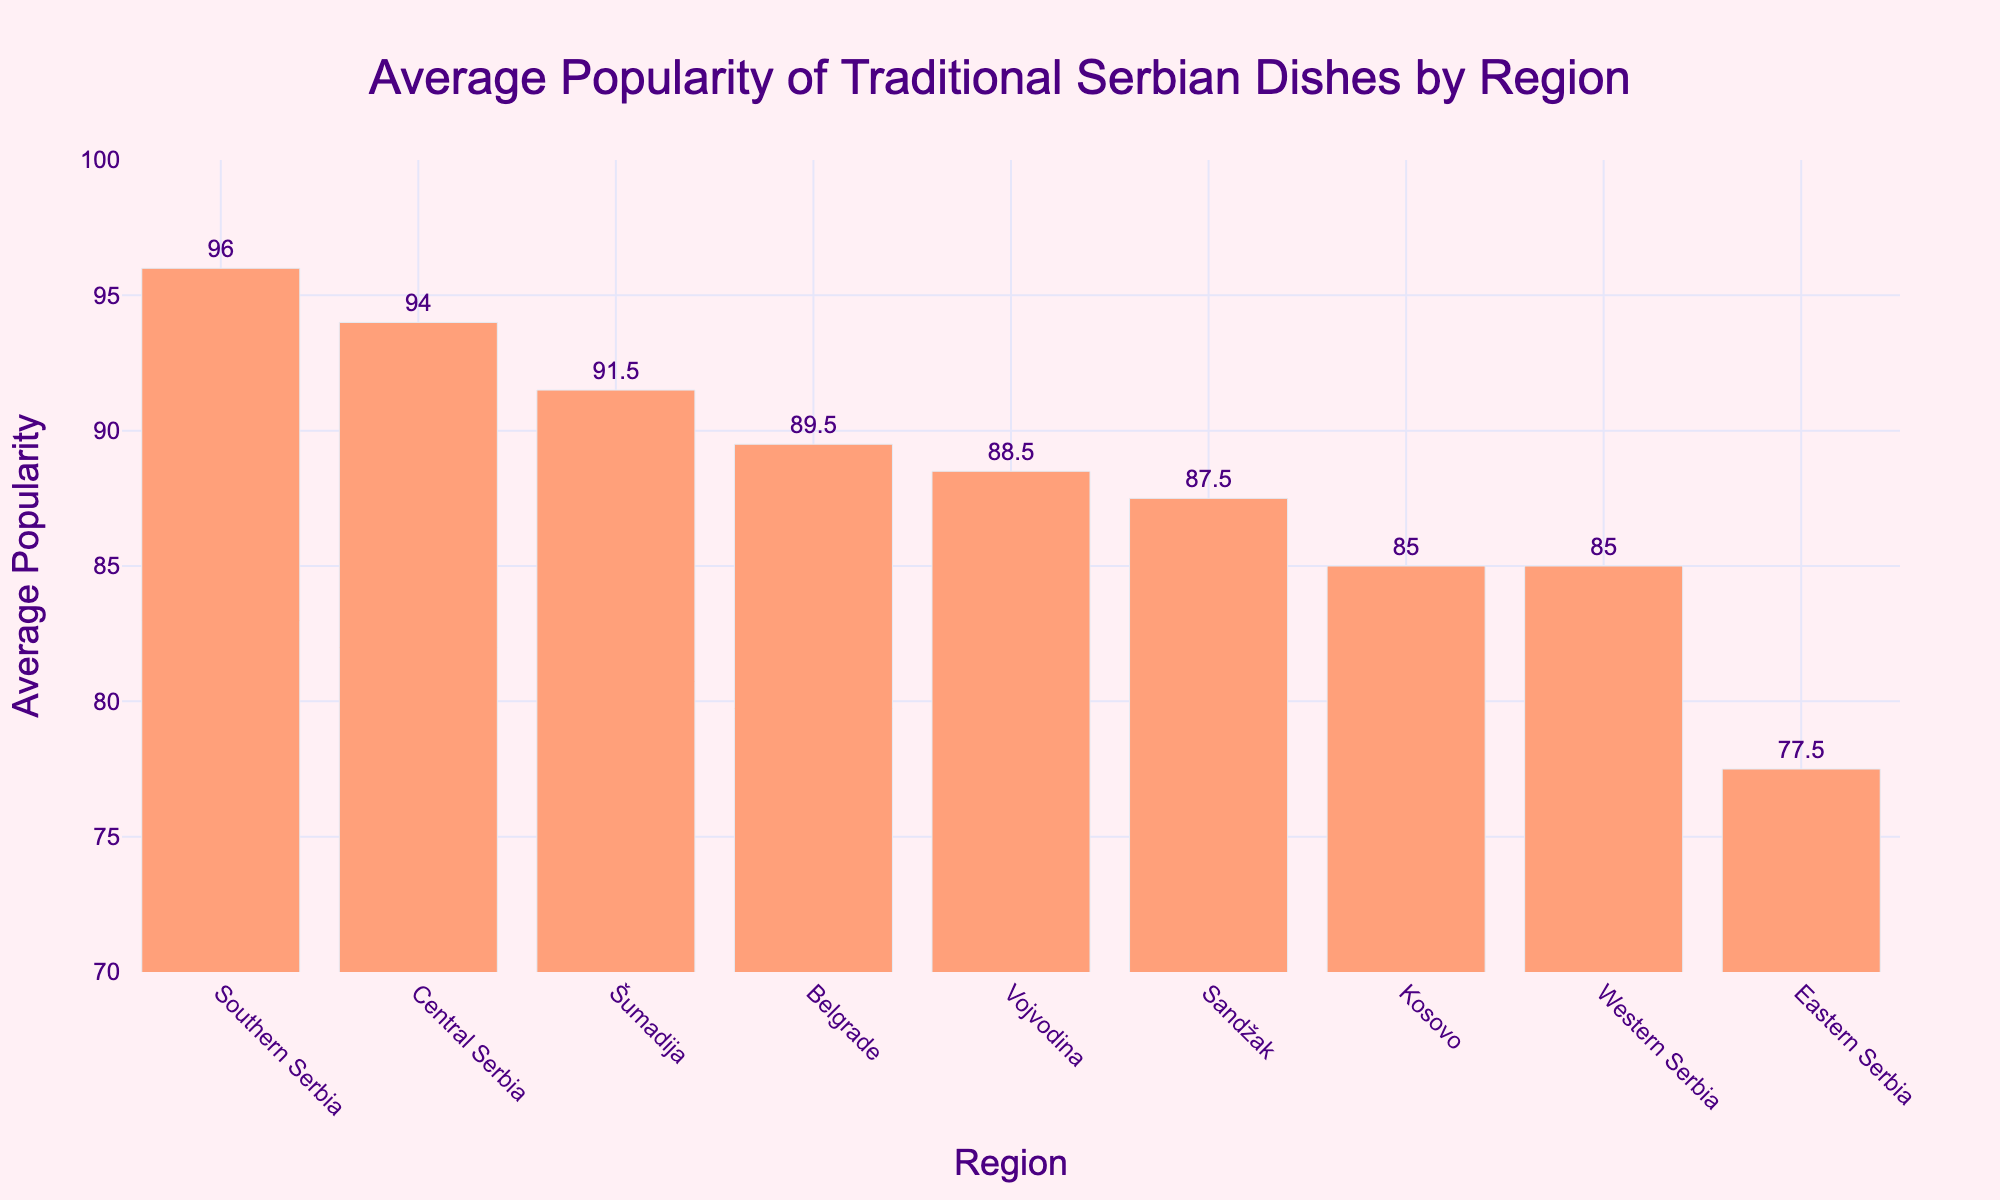Which region has the highest average popularity of traditional Serbian dishes? By looking at the heights of the bars in the bar chart, the bar for Central Serbia is the highest, indicating that this region has the highest average popularity of traditional Serbian dishes.
Answer: Central Serbia Which region has the lowest average popularity of traditional Serbian dishes? By examining the heights of the bars, the bar for Eastern Serbia is the shortest, indicating that this region has the lowest average popularity.
Answer: Eastern Serbia How does the average popularity of traditional dishes in Southern Serbia compare to those in Belgrade? The bar for Southern Serbia is taller compared to the bar for Belgrade, indicating that the average popularity in Southern Serbia is higher than in Belgrade.
Answer: Southern Serbia has a higher average popularity What is the difference in average popularity between Vojvodina and Western Serbia? The average popularity for Vojvodina is slightly higher than for Western Serbia. Vojvodina has an average popularity value of around 88.5, while Western Serbia has around 85, making the difference about 3.5.
Answer: 3.5 Which regions have an average popularity of over 90? By looking at the heights of the bars that extend beyond the 90-mark, Central Serbia, Southern Serbia, and Belgrade have average popularity values over 90.
Answer: Central Serbia, Southern Serbia, Belgrade Rank the regions from highest to lowest average popularity of traditional dishes. By comparing the heights of the bars from tallest to shortest, the ranking is as follows: Central Serbia, Southern Serbia, Belgrade, Šumadija, Vojvodina, Sandžak, Kosovo, Western Serbia, Eastern Serbia.
Answer: Central Serbia, Southern Serbia, Belgrade, Šumadija, Vojvodina, Sandžak, Kosovo, Western Serbia, Eastern Serbia What is the average popularity of traditional dishes in Šumadija? The bar representing Šumadija has a height that corresponds to an average popularity value of about 91.5.
Answer: 91.5 What is the total average popularity of dishes from Western Serbia and Sandžak together? Adding the average popularity of Western Serbia (around 85) and Sandžak (around 87.5) gives approximately 172.5.
Answer: 172.5 Do any regions have exactly the same average popularity? No two bars in the chart appear to have precisely the same height, indicating that no regions have exactly the same average popularity value.
Answer: No Which region has an average popularity closest to 85? By examining the bars, Western Serbia's average popularity is closest to 85, as it is approximately 85 itself.
Answer: Western Serbia 